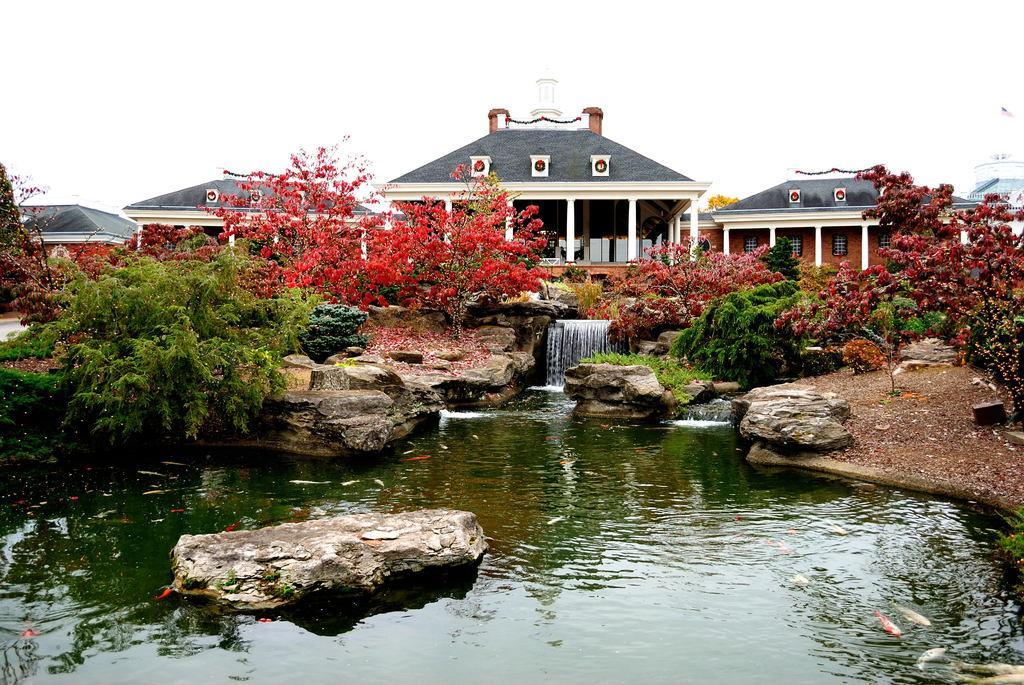How would you summarize this image in a sentence or two? In the center of the image we can see plants, rocks, water are present. In the background of the image building are there. At the top of the image sky is present. 